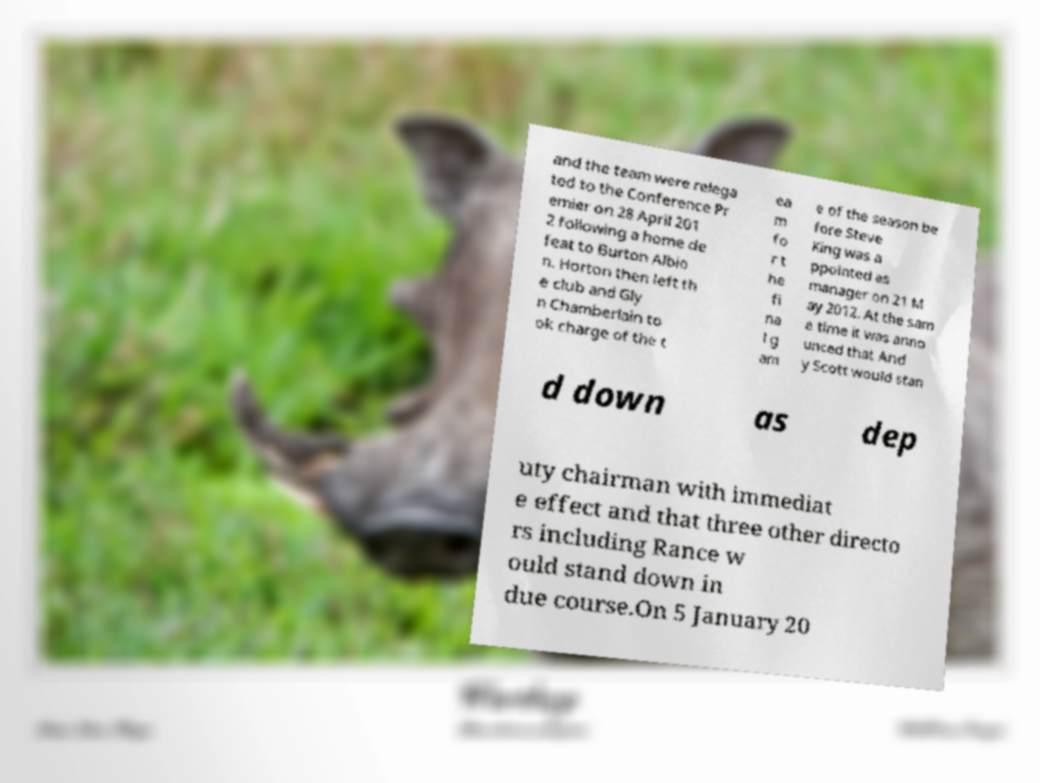Can you accurately transcribe the text from the provided image for me? and the team were relega ted to the Conference Pr emier on 28 April 201 2 following a home de feat to Burton Albio n. Horton then left th e club and Gly n Chamberlain to ok charge of the t ea m fo r t he fi na l g am e of the season be fore Steve King was a ppointed as manager on 21 M ay 2012. At the sam e time it was anno unced that And y Scott would stan d down as dep uty chairman with immediat e effect and that three other directo rs including Rance w ould stand down in due course.On 5 January 20 